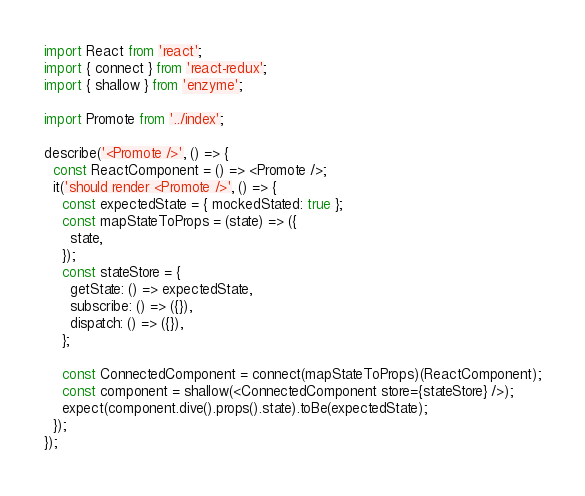Convert code to text. <code><loc_0><loc_0><loc_500><loc_500><_JavaScript_>import React from 'react';
import { connect } from 'react-redux';
import { shallow } from 'enzyme';

import Promote from '../index';

describe('<Promote />', () => {
  const ReactComponent = () => <Promote />;
  it('should render <Promote />', () => {
    const expectedState = { mockedStated: true };
    const mapStateToProps = (state) => ({
      state,
    });
    const stateStore = {
      getState: () => expectedState,
      subscribe: () => ({}),
      dispatch: () => ({}),
    };

    const ConnectedComponent = connect(mapStateToProps)(ReactComponent);
    const component = shallow(<ConnectedComponent store={stateStore} />);
    expect(component.dive().props().state).toBe(expectedState);
  });
});
</code> 